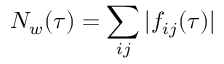Convert formula to latex. <formula><loc_0><loc_0><loc_500><loc_500>N _ { w } ( \tau ) = \sum _ { i j } | f _ { i j } ( \tau ) |</formula> 